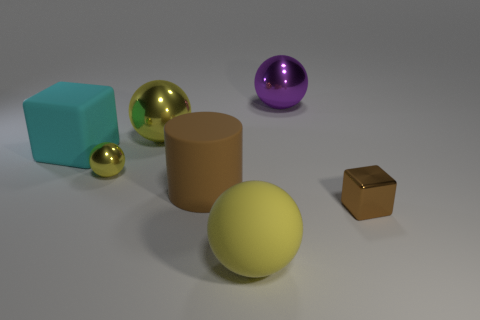What number of other things are there of the same material as the small yellow thing
Keep it short and to the point. 3. There is a block that is the same size as the brown rubber thing; what is its material?
Offer a terse response. Rubber. Is the number of large purple metal things left of the large cyan rubber thing less than the number of big brown rubber things?
Provide a succinct answer. Yes. What shape is the big yellow thing that is behind the big yellow thing that is in front of the small metal object that is in front of the tiny yellow ball?
Make the answer very short. Sphere. What size is the yellow object that is in front of the metal cube?
Give a very brief answer. Large. What is the shape of the yellow shiny object that is the same size as the yellow matte object?
Your answer should be very brief. Sphere. What number of things are either small yellow cubes or yellow things that are in front of the small brown metallic thing?
Make the answer very short. 1. What number of brown things are on the left side of the big thing that is on the right side of the yellow sphere in front of the brown block?
Your answer should be very brief. 1. The tiny sphere that is the same material as the brown block is what color?
Keep it short and to the point. Yellow. There is a metal object that is to the right of the purple metallic sphere; is it the same size as the brown matte cylinder?
Provide a succinct answer. No. 